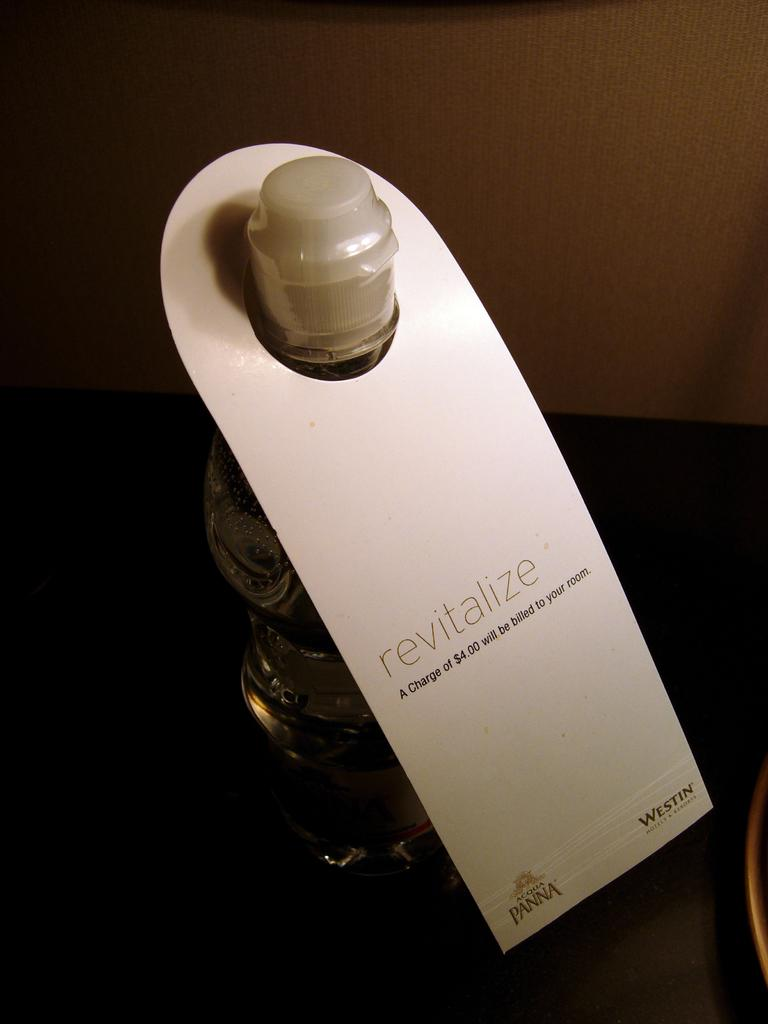<image>
Describe the image concisely. a bottle of water called revitalize which costs four dollars 